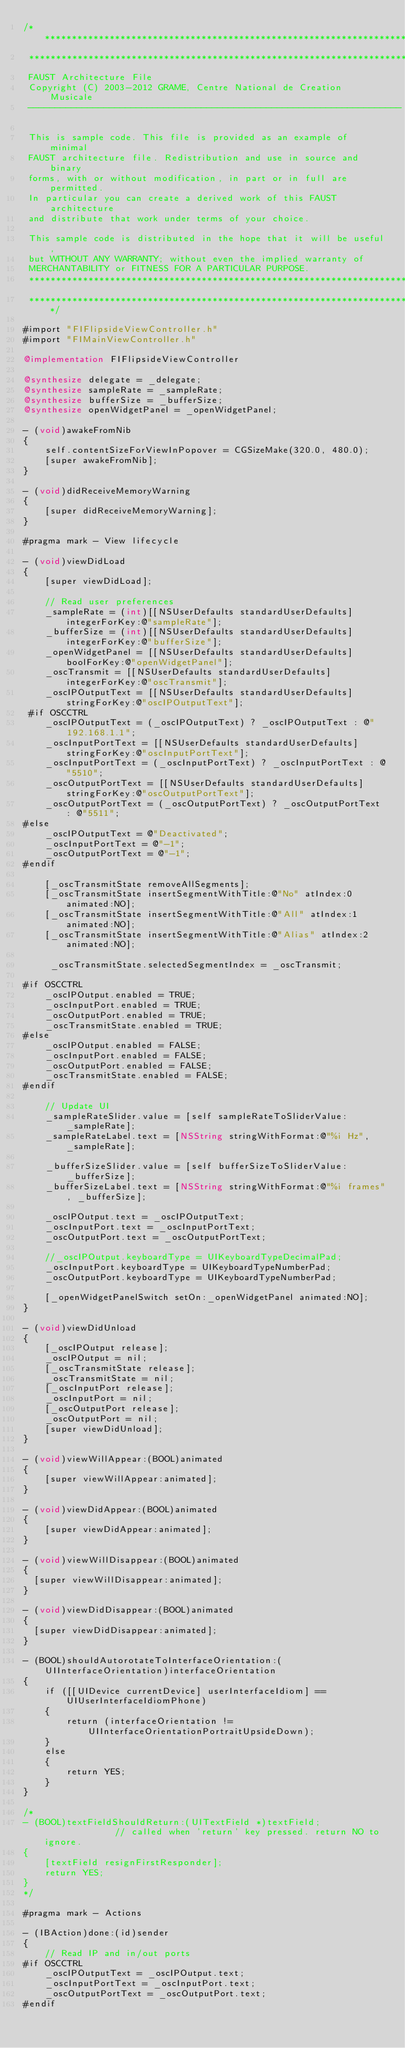Convert code to text. <code><loc_0><loc_0><loc_500><loc_500><_ObjectiveC_>/************************************************************************
 ************************************************************************
 FAUST Architecture File
 Copyright (C) 2003-2012 GRAME, Centre National de Creation Musicale
 ---------------------------------------------------------------------
 
 This is sample code. This file is provided as an example of minimal
 FAUST architecture file. Redistribution and use in source and binary
 forms, with or without modification, in part or in full are permitted.
 In particular you can create a derived work of this FAUST architecture
 and distribute that work under terms of your choice.
 
 This sample code is distributed in the hope that it will be useful,
 but WITHOUT ANY WARRANTY; without even the implied warranty of
 MERCHANTABILITY or FITNESS FOR A PARTICULAR PURPOSE.
 ************************************************************************
 ************************************************************************/

#import "FIFlipsideViewController.h"
#import "FIMainViewController.h"

@implementation FIFlipsideViewController

@synthesize delegate = _delegate;
@synthesize sampleRate = _sampleRate;
@synthesize bufferSize = _bufferSize;
@synthesize openWidgetPanel = _openWidgetPanel;

- (void)awakeFromNib
{
    self.contentSizeForViewInPopover = CGSizeMake(320.0, 480.0);
    [super awakeFromNib];
}

- (void)didReceiveMemoryWarning
{
    [super didReceiveMemoryWarning];
}

#pragma mark - View lifecycle

- (void)viewDidLoad
{
    [super viewDidLoad];
    
    // Read user preferences
    _sampleRate = (int)[[NSUserDefaults standardUserDefaults] integerForKey:@"sampleRate"];
    _bufferSize = (int)[[NSUserDefaults standardUserDefaults] integerForKey:@"bufferSize"];
    _openWidgetPanel = [[NSUserDefaults standardUserDefaults] boolForKey:@"openWidgetPanel"];
    _oscTransmit = [[NSUserDefaults standardUserDefaults] integerForKey:@"oscTransmit"];
    _oscIPOutputText = [[NSUserDefaults standardUserDefaults] stringForKey:@"oscIPOutputText"];
 #if OSCCTRL
    _oscIPOutputText = (_oscIPOutputText) ? _oscIPOutputText : @"192.168.1.1";
    _oscInputPortText = [[NSUserDefaults standardUserDefaults] stringForKey:@"oscInputPortText"];
    _oscInputPortText = (_oscInputPortText) ? _oscInputPortText : @"5510";
    _oscOutputPortText = [[NSUserDefaults standardUserDefaults] stringForKey:@"oscOutputPortText"];
    _oscOutputPortText = (_oscOutputPortText) ? _oscOutputPortText : @"5511";
#else
    _oscIPOutputText = @"Deactivated";
    _oscInputPortText = @"-1";
    _oscOutputPortText = @"-1";
#endif
    
    [_oscTransmitState removeAllSegments];
    [_oscTransmitState insertSegmentWithTitle:@"No" atIndex:0 animated:NO];
    [_oscTransmitState insertSegmentWithTitle:@"All" atIndex:1 animated:NO];
    [_oscTransmitState insertSegmentWithTitle:@"Alias" atIndex:2 animated:NO];
    
     _oscTransmitState.selectedSegmentIndex = _oscTransmit;
 
#if OSCCTRL
    _oscIPOutput.enabled = TRUE;
    _oscInputPort.enabled = TRUE;
    _oscOutputPort.enabled = TRUE;
    _oscTransmitState.enabled = TRUE;
#else
    _oscIPOutput.enabled = FALSE;
    _oscInputPort.enabled = FALSE;
    _oscOutputPort.enabled = FALSE;
    _oscTransmitState.enabled = FALSE;
#endif
    
    // Update UI
    _sampleRateSlider.value = [self sampleRateToSliderValue:_sampleRate];
    _sampleRateLabel.text = [NSString stringWithFormat:@"%i Hz", _sampleRate];
    
    _bufferSizeSlider.value = [self bufferSizeToSliderValue:_bufferSize];
    _bufferSizeLabel.text = [NSString stringWithFormat:@"%i frames", _bufferSize];

    _oscIPOutput.text = _oscIPOutputText;
    _oscInputPort.text = _oscInputPortText;
    _oscOutputPort.text = _oscOutputPortText;
    
    //_oscIPOutput.keyboardType = UIKeyboardTypeDecimalPad;
    _oscInputPort.keyboardType = UIKeyboardTypeNumberPad;
    _oscOutputPort.keyboardType = UIKeyboardTypeNumberPad;
    
    [_openWidgetPanelSwitch setOn:_openWidgetPanel animated:NO];
}

- (void)viewDidUnload
{
    [_oscIPOutput release];
    _oscIPOutput = nil;
    [_oscTransmitState release];
    _oscTransmitState = nil;
    [_oscInputPort release];
    _oscInputPort = nil;
    [_oscOutputPort release];
    _oscOutputPort = nil;
    [super viewDidUnload];
}

- (void)viewWillAppear:(BOOL)animated
{
    [super viewWillAppear:animated];
}

- (void)viewDidAppear:(BOOL)animated
{
    [super viewDidAppear:animated];
}

- (void)viewWillDisappear:(BOOL)animated
{
	[super viewWillDisappear:animated];
}

- (void)viewDidDisappear:(BOOL)animated
{
	[super viewDidDisappear:animated];
}

- (BOOL)shouldAutorotateToInterfaceOrientation:(UIInterfaceOrientation)interfaceOrientation
{
    if ([[UIDevice currentDevice] userInterfaceIdiom] == UIUserInterfaceIdiomPhone)
    {
        return (interfaceOrientation != UIInterfaceOrientationPortraitUpsideDown);
    }
    else
    {
        return YES;
    }
}

/*
- (BOOL)textFieldShouldReturn:(UITextField *)textField;              // called when 'return' key pressed. return NO to ignore.
{
    [textField resignFirstResponder];
    return YES;
}
*/

#pragma mark - Actions

- (IBAction)done:(id)sender
{
    // Read IP and in/out ports
#if OSCCTRL
    _oscIPOutputText = _oscIPOutput.text;
    _oscInputPortText = _oscInputPort.text;
    _oscOutputPortText = _oscOutputPort.text;
#endif</code> 